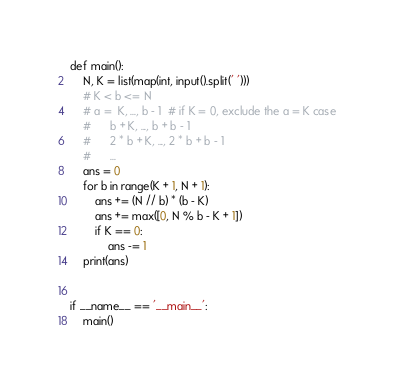Convert code to text. <code><loc_0><loc_0><loc_500><loc_500><_Python_>def main():
    N, K = list(map(int, input().split(' ')))
    # K < b <= N
    # a =  K, ..., b - 1  # if K = 0, exclude the a = K case
    #      b + K, ..., b + b - 1
    #      2 * b + K, ..., 2 * b + b - 1
    #      ...
    ans = 0
    for b in range(K + 1, N + 1):
        ans += (N // b) * (b - K)
        ans += max([0, N % b - K + 1])
        if K == 0:
            ans -= 1
    print(ans)


if __name__ == '__main__':
    main()
</code> 